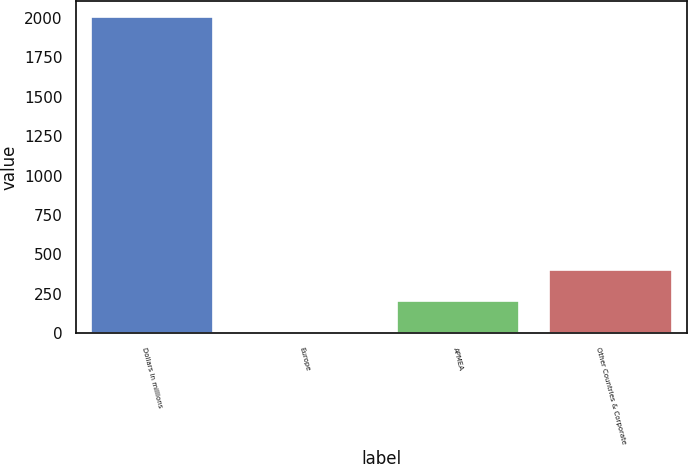<chart> <loc_0><loc_0><loc_500><loc_500><bar_chart><fcel>Dollars in millions<fcel>Europe<fcel>APMEA<fcel>Other Countries & Corporate<nl><fcel>2008<fcel>1<fcel>201.7<fcel>402.4<nl></chart> 